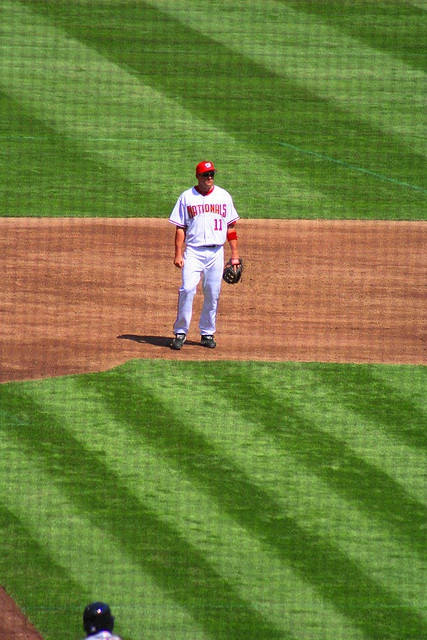Describe the objects in this image and their specific colors. I can see people in olive, lavender, violet, gray, and maroon tones and baseball glove in olive, black, maroon, gray, and brown tones in this image. 